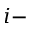Convert formula to latex. <formula><loc_0><loc_0><loc_500><loc_500>i -</formula> 